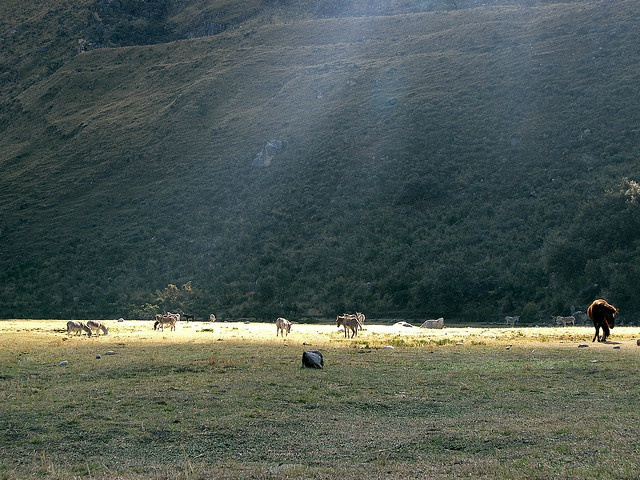Describe the objects in this image and their specific colors. I can see horse in purple, black, maroon, and tan tones, horse in purple, gray, olive, black, and tan tones, horse in purple, black, and gray tones, horse in purple, gray, tan, and ivory tones, and horse in purple, gray, tan, and darkgray tones in this image. 